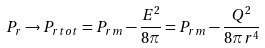Convert formula to latex. <formula><loc_0><loc_0><loc_500><loc_500>P _ { r } \rightarrow { P _ { r } } _ { t o t } = { P _ { r } } _ { m } - \frac { E ^ { 2 } } { 8 \pi } = { P _ { r } } _ { m } - \frac { Q ^ { 2 } } { 8 \pi r ^ { 4 } }</formula> 